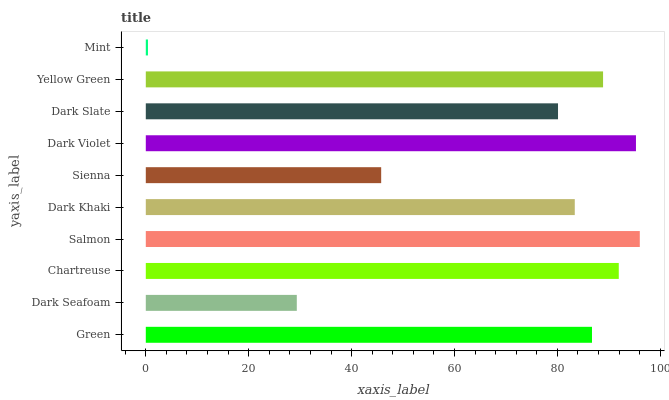Is Mint the minimum?
Answer yes or no. Yes. Is Salmon the maximum?
Answer yes or no. Yes. Is Dark Seafoam the minimum?
Answer yes or no. No. Is Dark Seafoam the maximum?
Answer yes or no. No. Is Green greater than Dark Seafoam?
Answer yes or no. Yes. Is Dark Seafoam less than Green?
Answer yes or no. Yes. Is Dark Seafoam greater than Green?
Answer yes or no. No. Is Green less than Dark Seafoam?
Answer yes or no. No. Is Green the high median?
Answer yes or no. Yes. Is Dark Khaki the low median?
Answer yes or no. Yes. Is Dark Khaki the high median?
Answer yes or no. No. Is Chartreuse the low median?
Answer yes or no. No. 